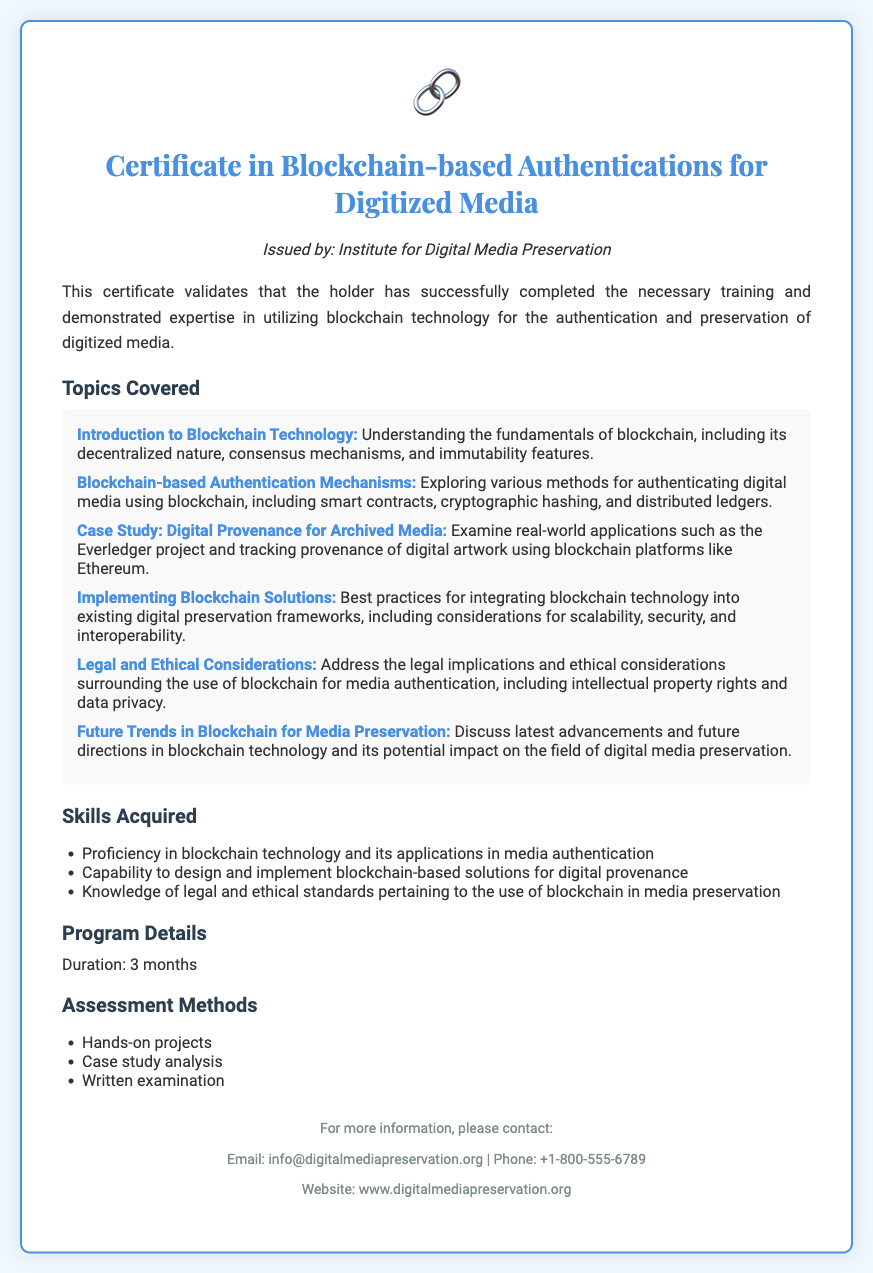What is the title of the certificate? The title of the certificate is mentioned at the top of the document.
Answer: Certificate in Blockchain-based Authentications for Digitized Media Who issued the certificate? The issuer's name is indicated below the title of the certificate.
Answer: Institute for Digital Media Preservation What is the duration of the program? The duration is specified in the section titled "Program Details."
Answer: 3 months Name one method for authenticating digital media using blockchain. This requires recalling specific topics discussed in the document, particularly the section on authentication mechanisms.
Answer: Smart contracts What are the assessment methods mentioned? This refers to the section outlining how learners are evaluated in the program.
Answer: Hands-on projects Which topic covers the ethical implications of blockchain? This requires reasoning about the topics discussed, specifically focusing on ethical considerations.
Answer: Legal and Ethical Considerations List one skill acquired from this certificate program. The skills listed in the relevant section indicate what participants will gain.
Answer: Proficiency in blockchain technology What is the contact email for more information? This can be found in the footer section of the certificate.
Answer: info@digitalmediapreservation.org What future aspect is discussed regarding blockchain? The document highlights future trends in a specific section on potential advancements.
Answer: Future Trends in Blockchain for Media Preservation 